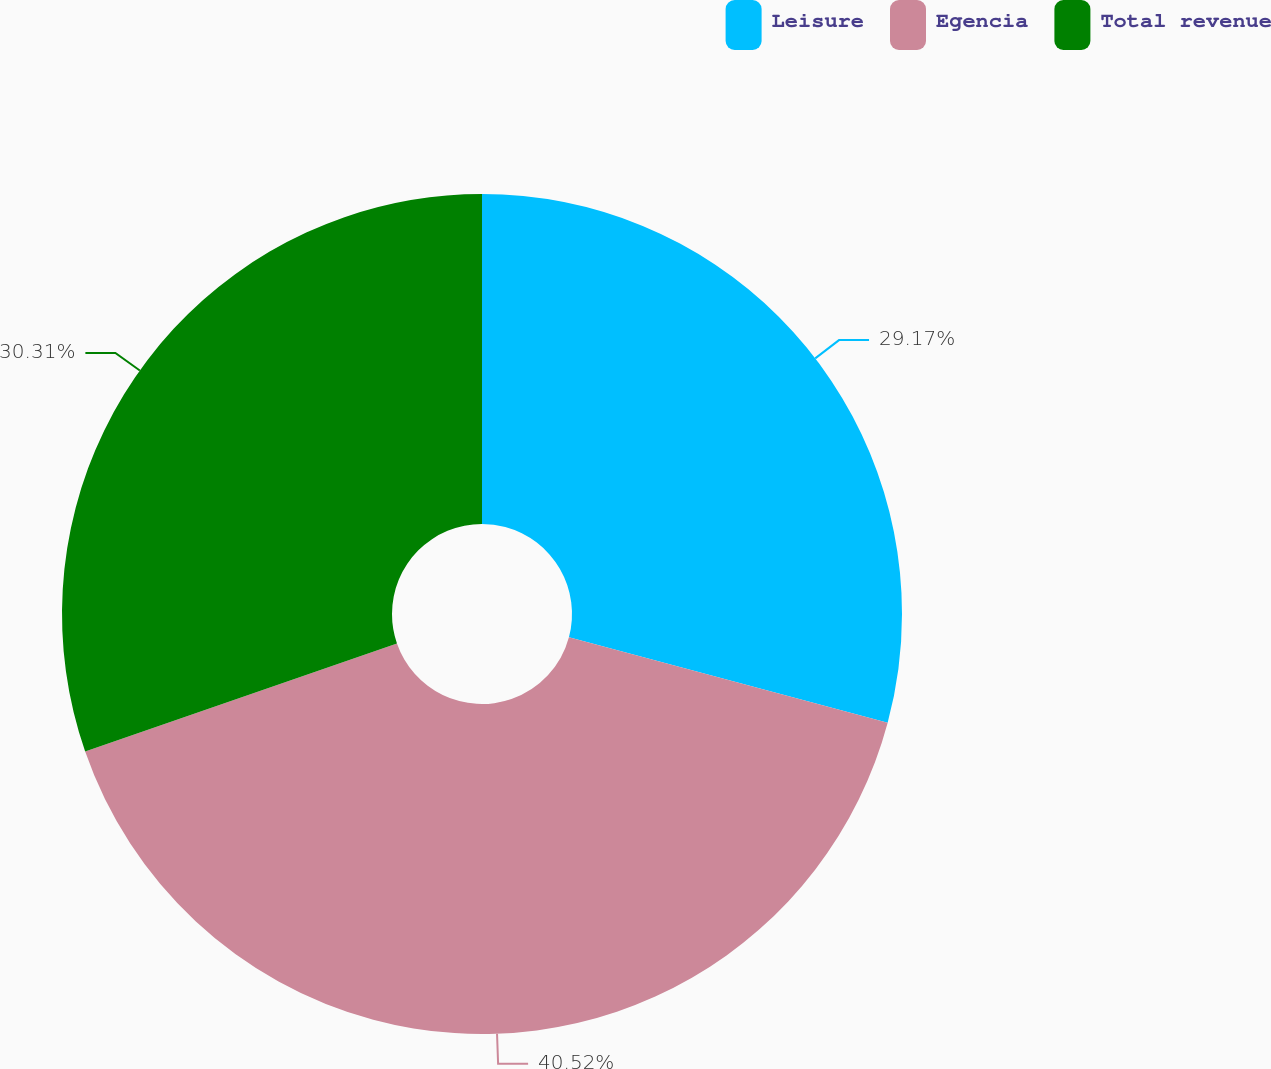<chart> <loc_0><loc_0><loc_500><loc_500><pie_chart><fcel>Leisure<fcel>Egencia<fcel>Total revenue<nl><fcel>29.17%<fcel>40.52%<fcel>30.31%<nl></chart> 